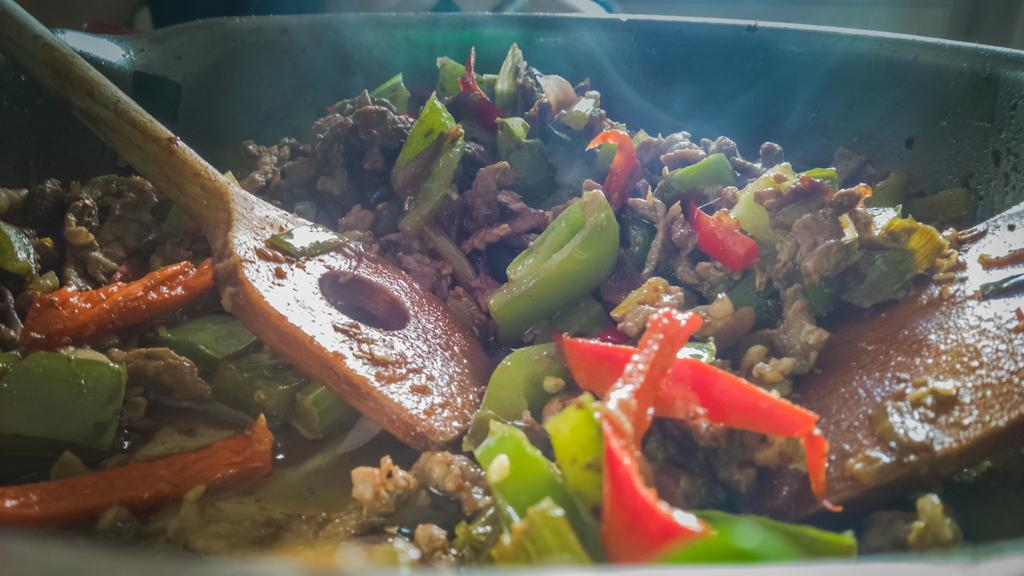What is in the bowl that is visible in the image? There is food in the bowl. What utensils are present in the bowl? There are ladles in the bowl. What is the price of the skin in the image? There is no skin or price mentioned in the image; it only shows food and ladles in a bowl. 